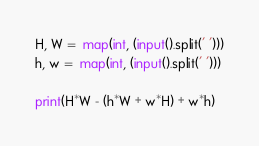Convert code to text. <code><loc_0><loc_0><loc_500><loc_500><_Python_>H, W =  map(int, (input().split(' ')))
h, w =  map(int, (input().split(' ')))

print(H*W - (h*W + w*H) + w*h)</code> 